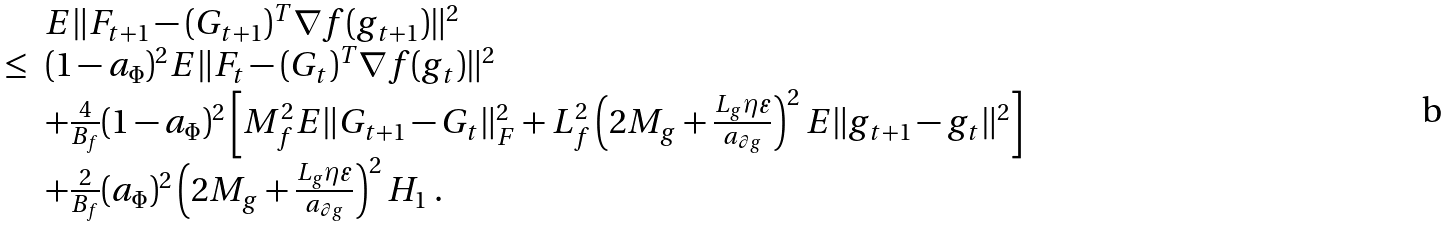Convert formula to latex. <formula><loc_0><loc_0><loc_500><loc_500>\begin{array} { l l } & E \| F _ { t + 1 } - ( G _ { t + 1 } ) ^ { T } \nabla f ( g _ { t + 1 } ) \| ^ { 2 } \\ \leq & ( 1 - a _ { \Phi } ) ^ { 2 } E \| F _ { t } - ( G _ { t } ) ^ { T } \nabla f ( g _ { t } ) \| ^ { 2 } \\ & + \frac { 4 } { B _ { f } } ( 1 - a _ { \Phi } ) ^ { 2 } \left [ M _ { f } ^ { 2 } E \| G _ { t + 1 } - G _ { t } \| _ { F } ^ { 2 } + L _ { f } ^ { 2 } \left ( 2 M _ { g } + \frac { L _ { g } \eta \varepsilon } { a _ { \partial g } } \right ) ^ { 2 } E \| g _ { t + 1 } - g _ { t } \| ^ { 2 } \right ] \\ & + \frac { 2 } { B _ { f } } ( a _ { \Phi } ) ^ { 2 } \left ( 2 M _ { g } + \frac { L _ { g } \eta \varepsilon } { a _ { \partial g } } \right ) ^ { 2 } H _ { 1 } \ . \end{array}</formula> 